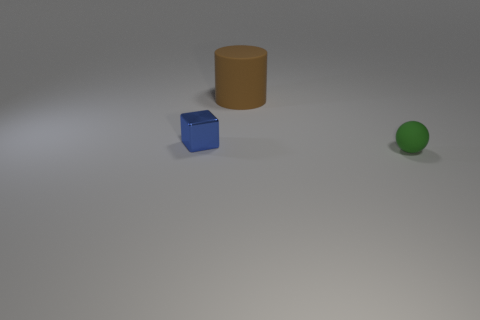Does the brown rubber thing have the same size as the rubber object in front of the blue object?
Your answer should be compact. No. What number of small objects are to the right of the small thing that is behind the tiny object in front of the small blue shiny thing?
Give a very brief answer. 1. What number of cubes are on the left side of the matte ball?
Ensure brevity in your answer.  1. What is the color of the matte thing that is behind the tiny thing in front of the blue metallic thing?
Ensure brevity in your answer.  Brown. What number of other objects are the same material as the small sphere?
Offer a very short reply. 1. Is the number of metal cubes behind the blue block the same as the number of yellow shiny objects?
Your answer should be compact. Yes. What material is the object on the right side of the rubber thing that is on the left side of the matte object in front of the small shiny cube?
Make the answer very short. Rubber. What is the color of the matte thing behind the blue metal object?
Your answer should be very brief. Brown. Is there any other thing that has the same shape as the tiny blue thing?
Your answer should be compact. No. What is the size of the rubber object behind the object to the right of the big brown cylinder?
Keep it short and to the point. Large. 